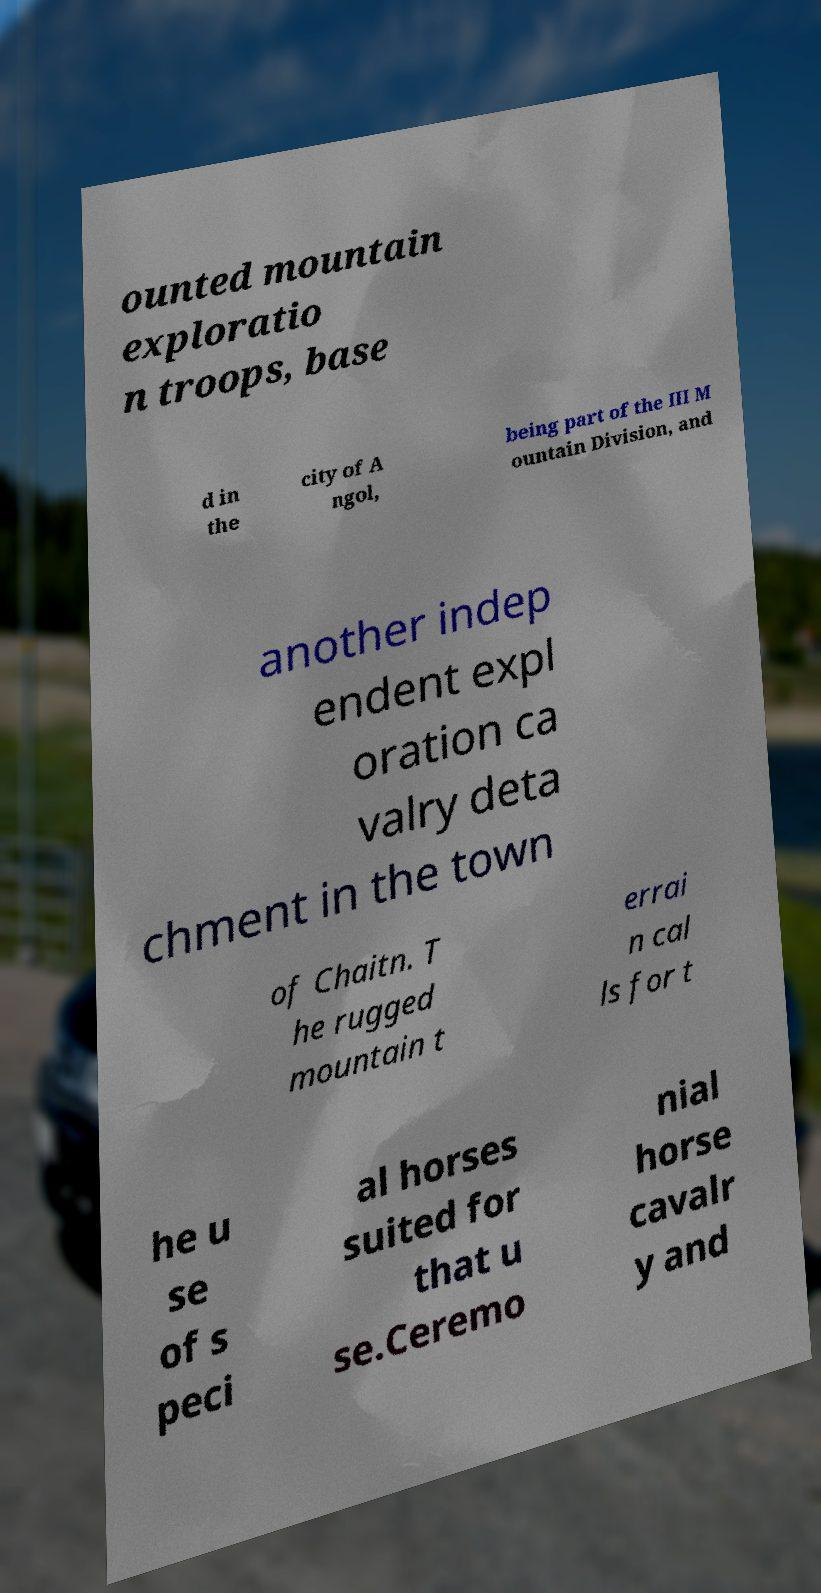For documentation purposes, I need the text within this image transcribed. Could you provide that? ounted mountain exploratio n troops, base d in the city of A ngol, being part of the III M ountain Division, and another indep endent expl oration ca valry deta chment in the town of Chaitn. T he rugged mountain t errai n cal ls for t he u se of s peci al horses suited for that u se.Ceremo nial horse cavalr y and 